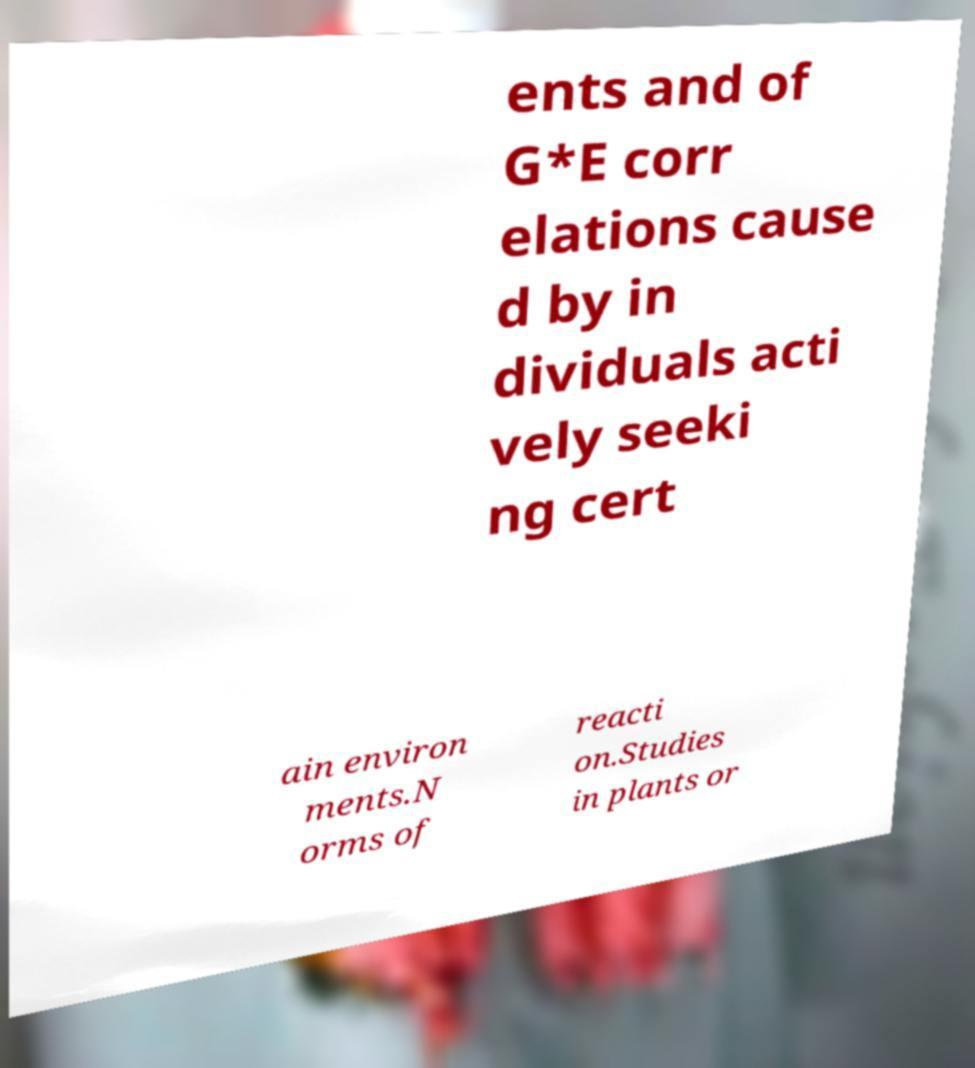Can you accurately transcribe the text from the provided image for me? ents and of G*E corr elations cause d by in dividuals acti vely seeki ng cert ain environ ments.N orms of reacti on.Studies in plants or 